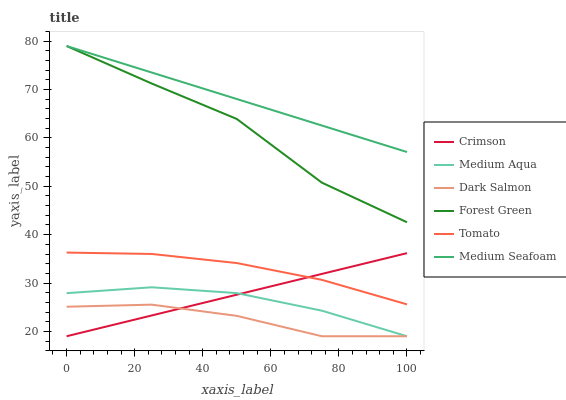Does Forest Green have the minimum area under the curve?
Answer yes or no. No. Does Forest Green have the maximum area under the curve?
Answer yes or no. No. Is Dark Salmon the smoothest?
Answer yes or no. No. Is Dark Salmon the roughest?
Answer yes or no. No. Does Forest Green have the lowest value?
Answer yes or no. No. Does Dark Salmon have the highest value?
Answer yes or no. No. Is Tomato less than Forest Green?
Answer yes or no. Yes. Is Forest Green greater than Medium Aqua?
Answer yes or no. Yes. Does Tomato intersect Forest Green?
Answer yes or no. No. 